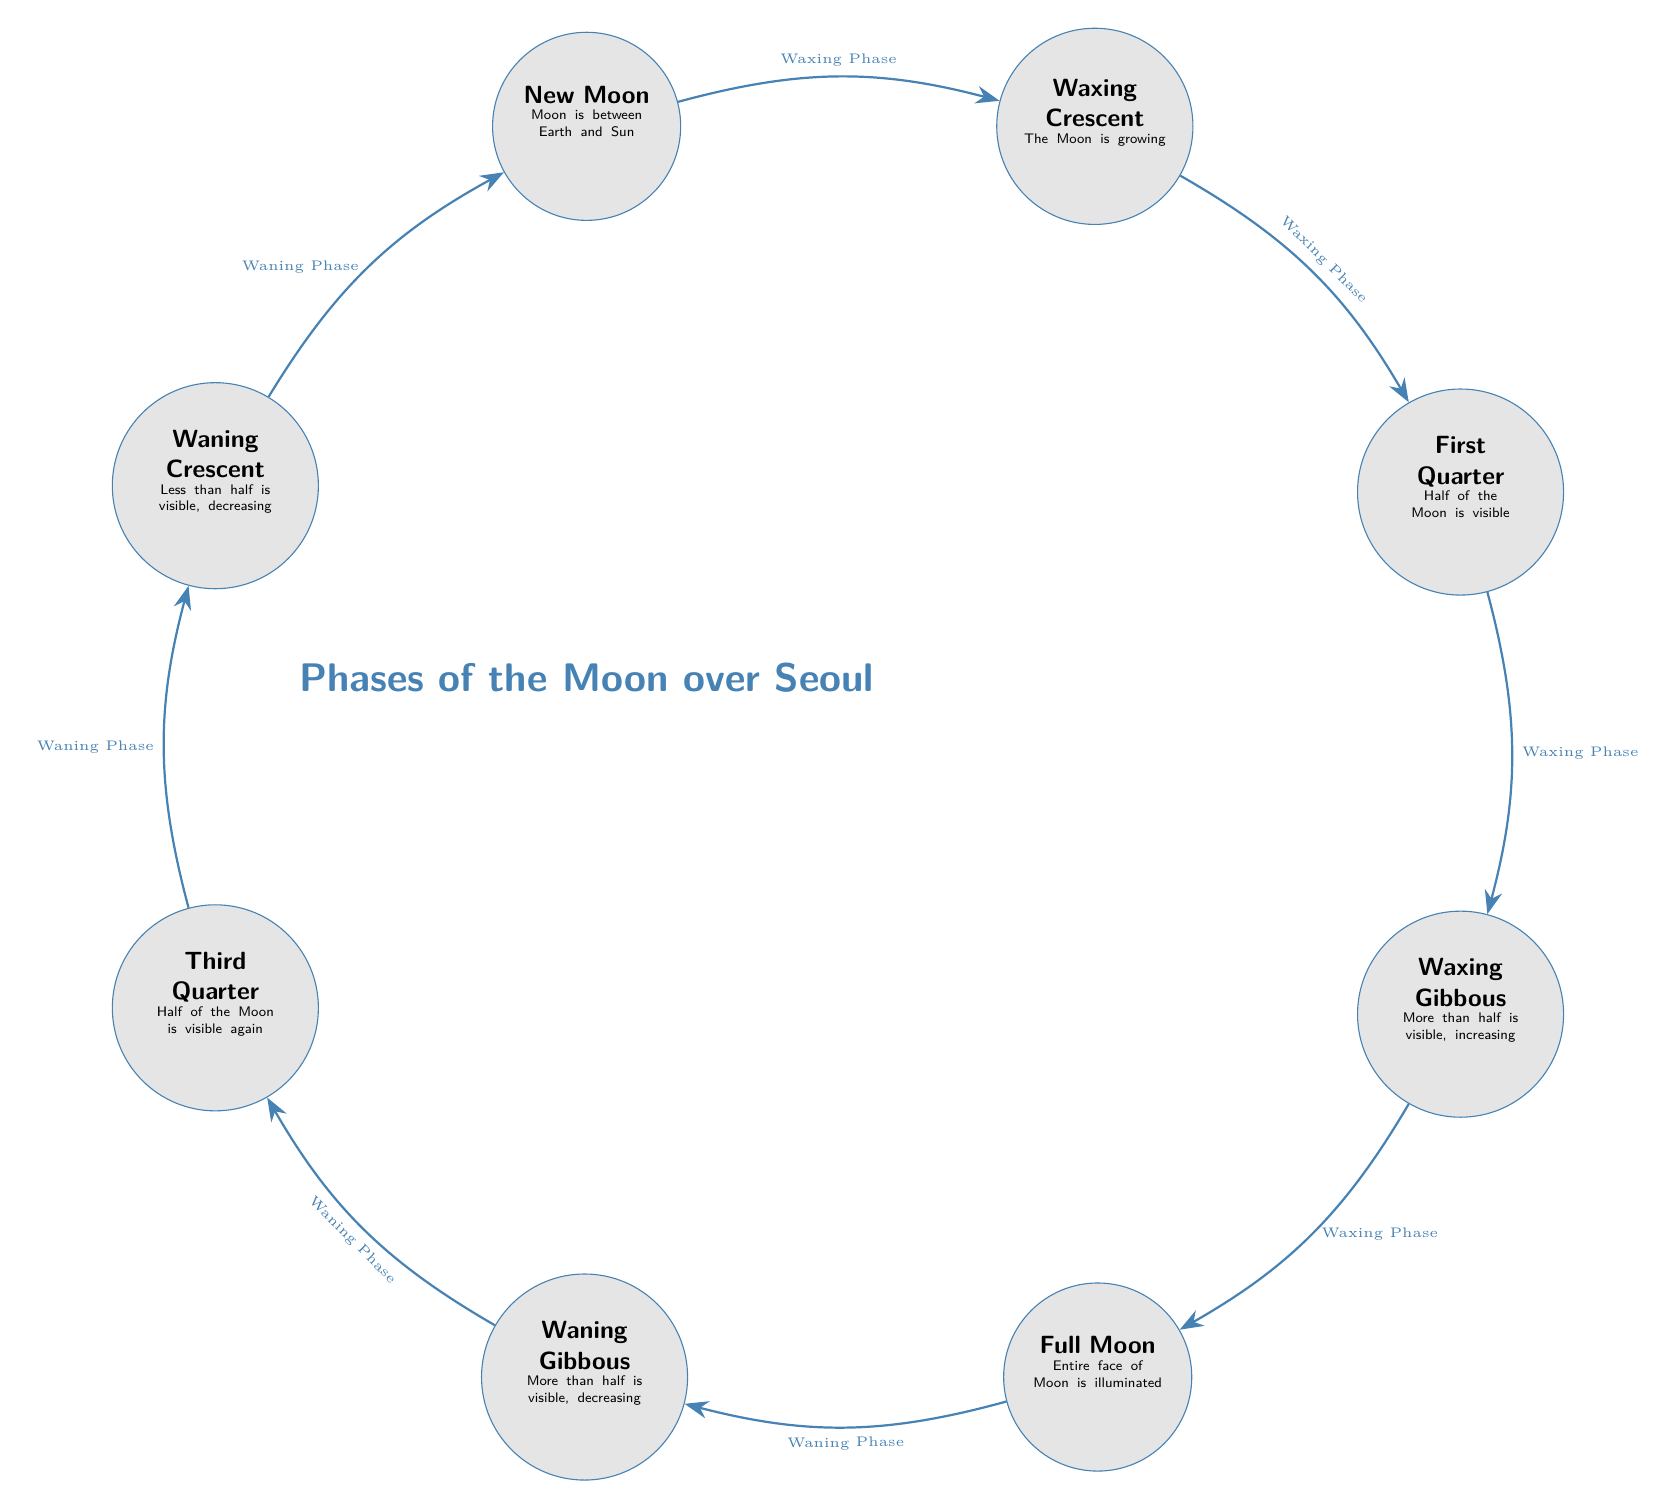What is the first phase of the Moon depicted in the diagram? The first phase shown in the diagram, starting from the left, is the New Moon. This is identified as the first node and is labeled explicitly.
Answer: New Moon How many phases of the Moon are illustrated in the diagram? The diagram shows a total of eight phases of the Moon, each represented by a distinct node in the sequence.
Answer: Eight What does the arrow from New Moon to Waxing Crescent indicate? The arrow from New Moon to Waxing Crescent signifies a transition, specifically from the New Moon phase to the Waxing Crescent phase, indicating a growth in the visible portion of the Moon.
Answer: Waxing Phase Which phase comes directly after the First Quarter? Following the First Quarter in the sequence of the Moon phases is the Waxing Gibbous phase, which is shown directly below it in the diagram.
Answer: Waxing Gibbous What is the last phase before returning to New Moon? The last phase depicted before cycling back to New Moon is the Waning Crescent, which is illustrated at the top left of the diagram just before flowing back to the New Moon phase.
Answer: Waning Crescent How many phases are associated with the Waxing Phase? There are four phases associated with the Waxing Phase in the diagram: New Moon, Waxing Crescent, First Quarter, and Waxing Gibbous, as indicated by the arrows leading in the upward direction.
Answer: Four What shape is used to represent the Moon in the diagram? The shape used to represent each phase of the Moon in the diagram is a circle, as can be seen for all the nodes where the phases are illustrated.
Answer: Circle Which phase has the entire face of the Moon illuminated? The phase where the entire face of the Moon is illuminated is the Full Moon, clearly labeled in the diagram, indicating maximum visibility.
Answer: Full Moon 